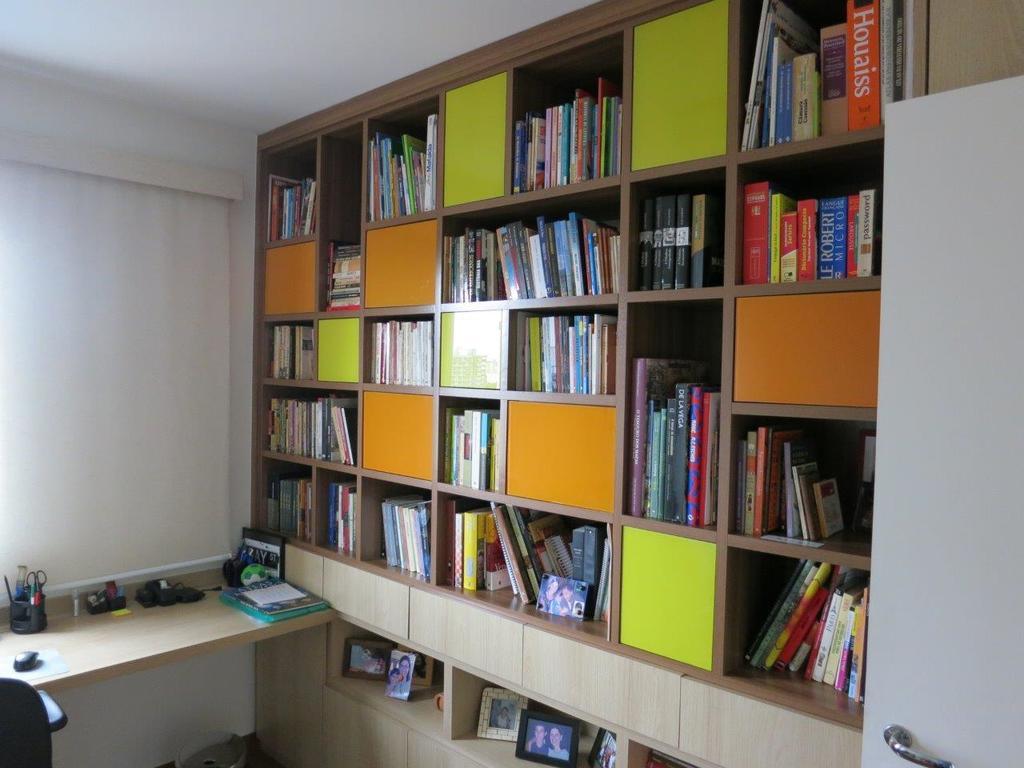What is the title of the large orange book on the top right?
Provide a succinct answer. Houaiss. Who is the author of the big blue book on the right second shelf?
Your response must be concise. Robert. 